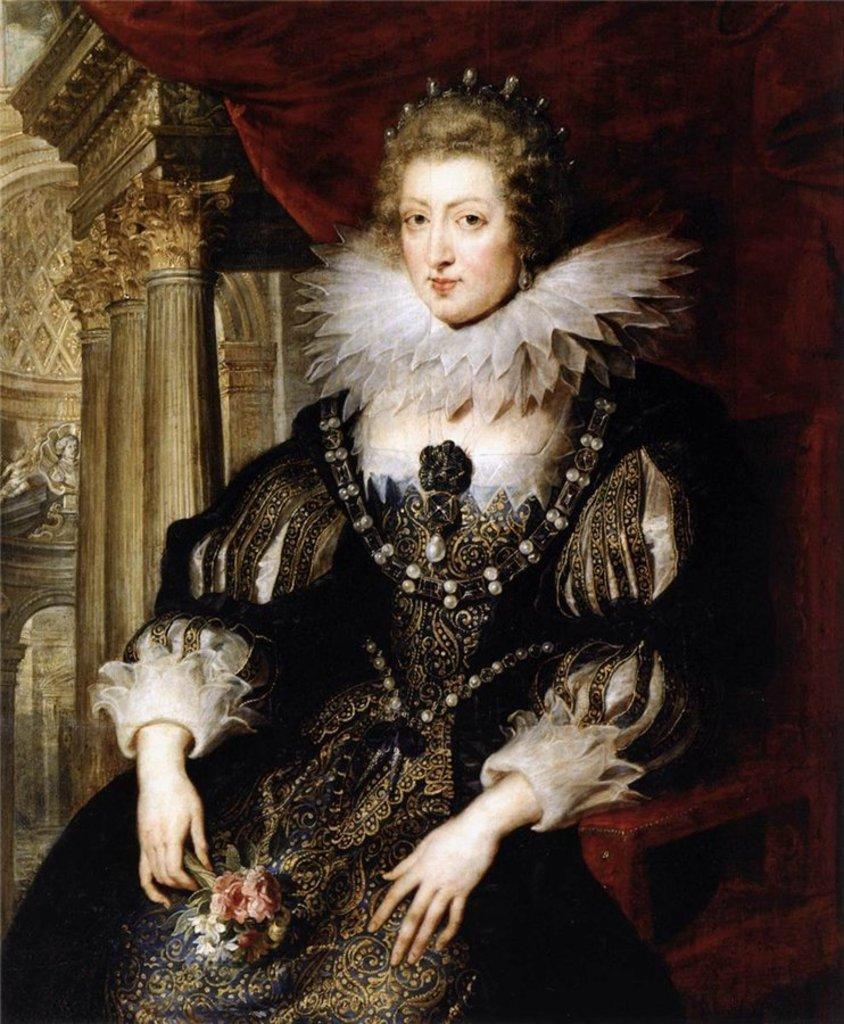How would you summarize this image in a sentence or two? This picture shows a painting of a woman seated on the chair. 